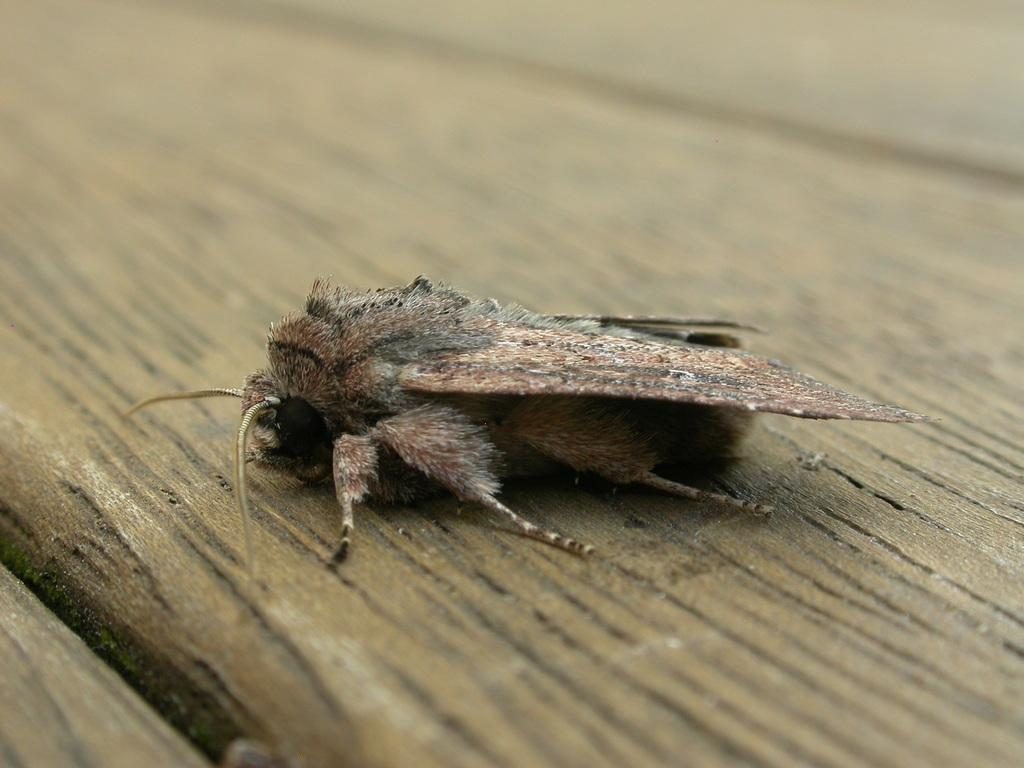What type of creature can be seen in the image? There is an insect in the image. Where is the insect located? The insect is on a platform. How many legs does the stranger have in the image? There is no stranger present in the image, so it is not possible to determine the number of legs they might have. 